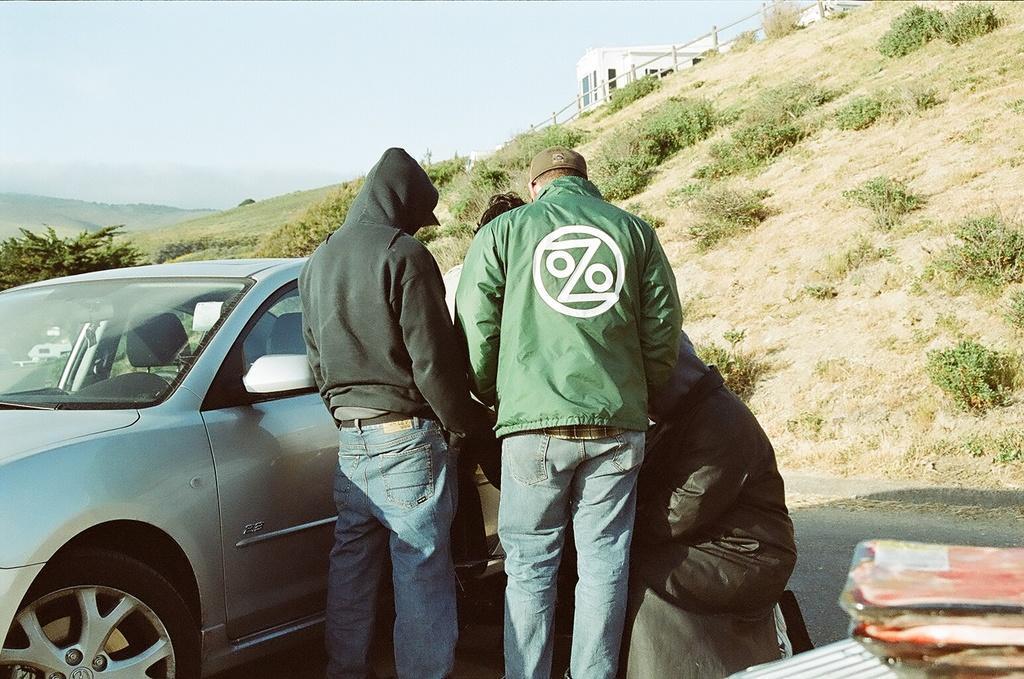How would you summarize this image in a sentence or two? In the image there are few people. In front of them there is a car. In the bottom right corner of the image there are few items. In the background there is a hill with grass. On the top of the hill there is a railing. Behind the railing there is a building with glass windows. At the top of the image there is sky. Behind the car there is a tree. 